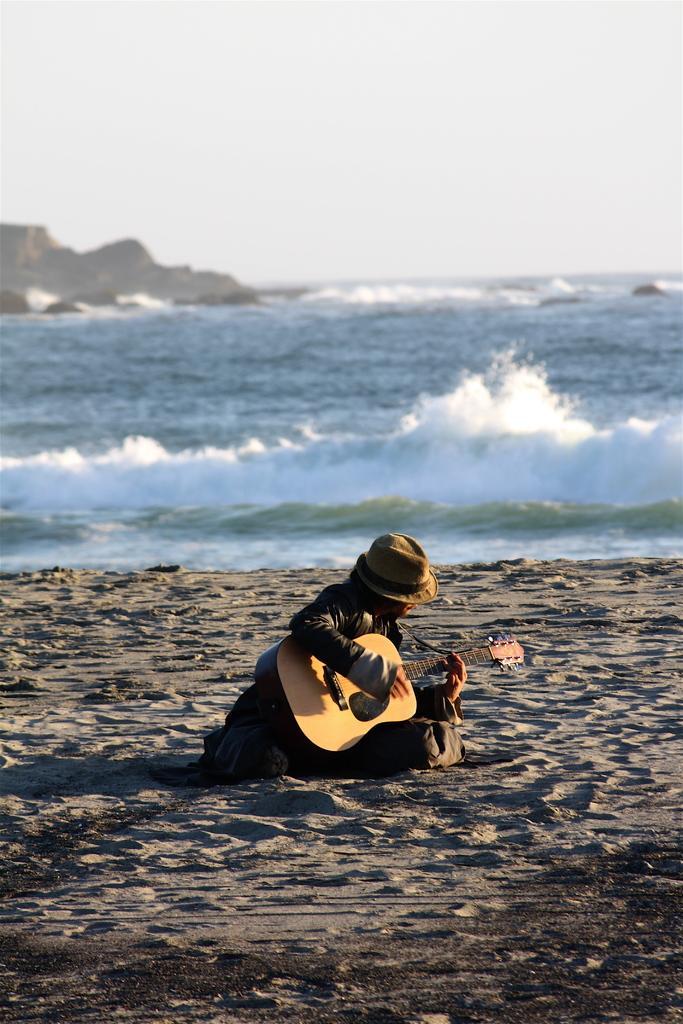Please provide a concise description of this image. In the given image we can see a person sitting and having a guitar in their hand. This is a cap, sand , water, rock and a white sky. 